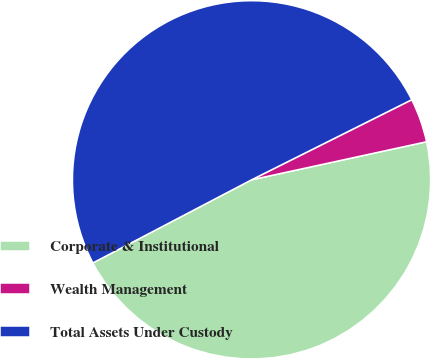Convert chart. <chart><loc_0><loc_0><loc_500><loc_500><pie_chart><fcel>Corporate & Institutional<fcel>Wealth Management<fcel>Total Assets Under Custody<nl><fcel>45.73%<fcel>3.97%<fcel>50.3%<nl></chart> 